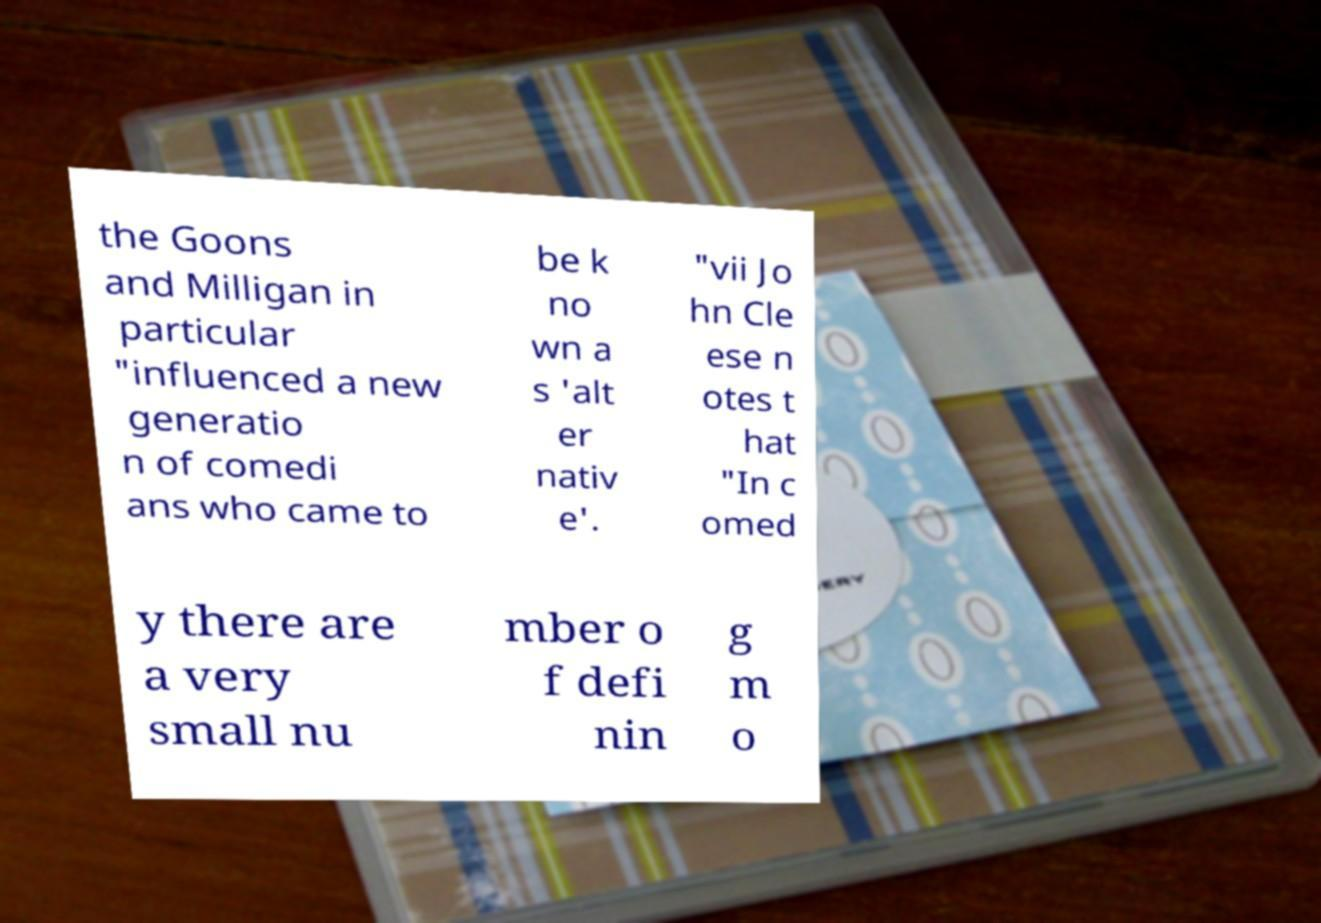What messages or text are displayed in this image? I need them in a readable, typed format. the Goons and Milligan in particular "influenced a new generatio n of comedi ans who came to be k no wn a s 'alt er nativ e'. "vii Jo hn Cle ese n otes t hat "In c omed y there are a very small nu mber o f defi nin g m o 